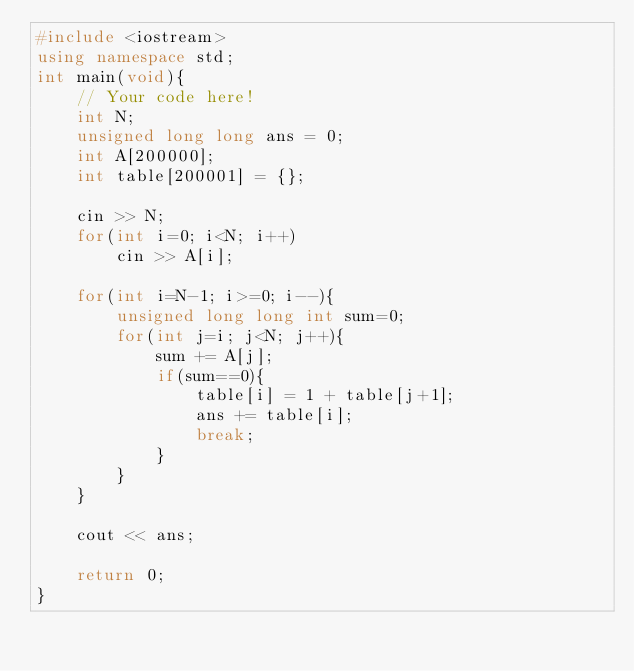Convert code to text. <code><loc_0><loc_0><loc_500><loc_500><_C++_>#include <iostream>
using namespace std;
int main(void){
    // Your code here!
    int N;
    unsigned long long ans = 0;
    int A[200000];
    int table[200001] = {};
    
    cin >> N;
    for(int i=0; i<N; i++)
        cin >> A[i];
        
    for(int i=N-1; i>=0; i--){
        unsigned long long int sum=0;
        for(int j=i; j<N; j++){
            sum += A[j];
            if(sum==0){
                table[i] = 1 + table[j+1];
                ans += table[i];
                break;
            }
        }
    }
    
    cout << ans;
    
    return 0;
}
</code> 